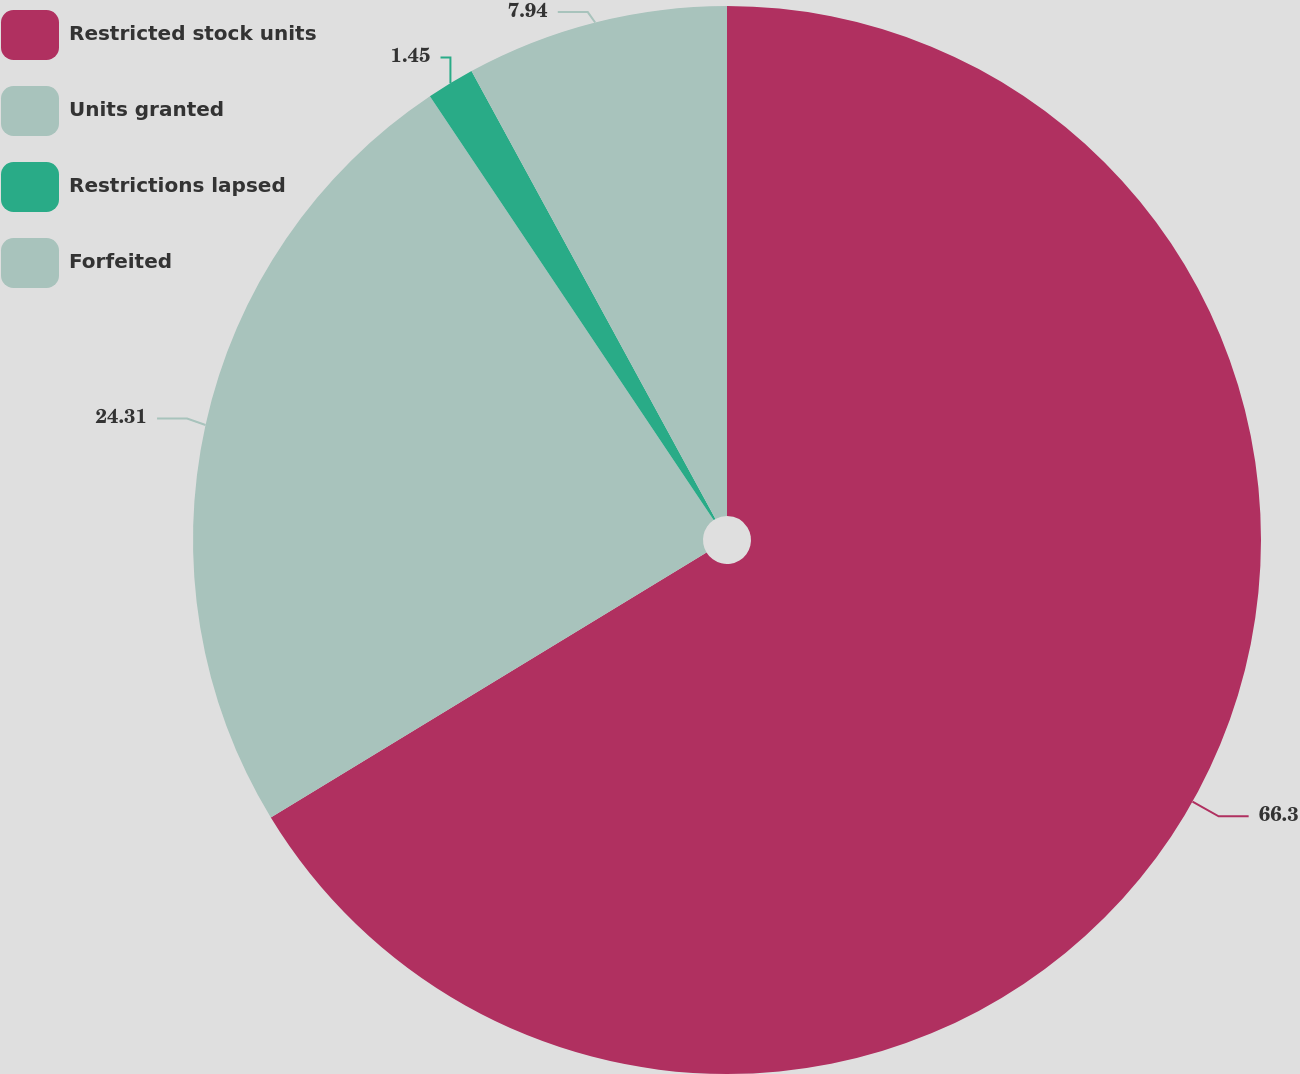Convert chart. <chart><loc_0><loc_0><loc_500><loc_500><pie_chart><fcel>Restricted stock units<fcel>Units granted<fcel>Restrictions lapsed<fcel>Forfeited<nl><fcel>66.3%<fcel>24.31%<fcel>1.45%<fcel>7.94%<nl></chart> 